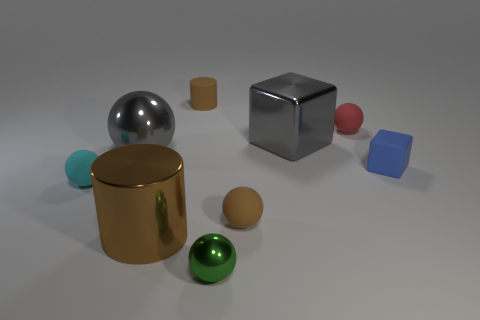Are there any metal blocks?
Your response must be concise. Yes. How big is the brown cylinder in front of the gray thing that is to the left of the tiny brown thing that is behind the small blue cube?
Give a very brief answer. Large. What shape is the blue object that is the same size as the red matte thing?
Make the answer very short. Cube. Is there anything else that has the same material as the gray block?
Keep it short and to the point. Yes. How many objects are either large gray metallic objects on the right side of the large brown shiny object or large cyan matte cylinders?
Provide a succinct answer. 1. There is a brown thing that is behind the small red object that is to the right of the large brown shiny thing; is there a small matte ball that is in front of it?
Your answer should be very brief. Yes. What number of tiny brown things are there?
Your response must be concise. 2. How many things are balls right of the tiny rubber cylinder or gray metal things that are to the left of the tiny metallic thing?
Offer a very short reply. 4. There is a gray object on the right side of the brown rubber cylinder; does it have the same size as the tiny shiny ball?
Keep it short and to the point. No. There is a brown matte thing that is the same shape as the small green thing; what size is it?
Offer a terse response. Small. 